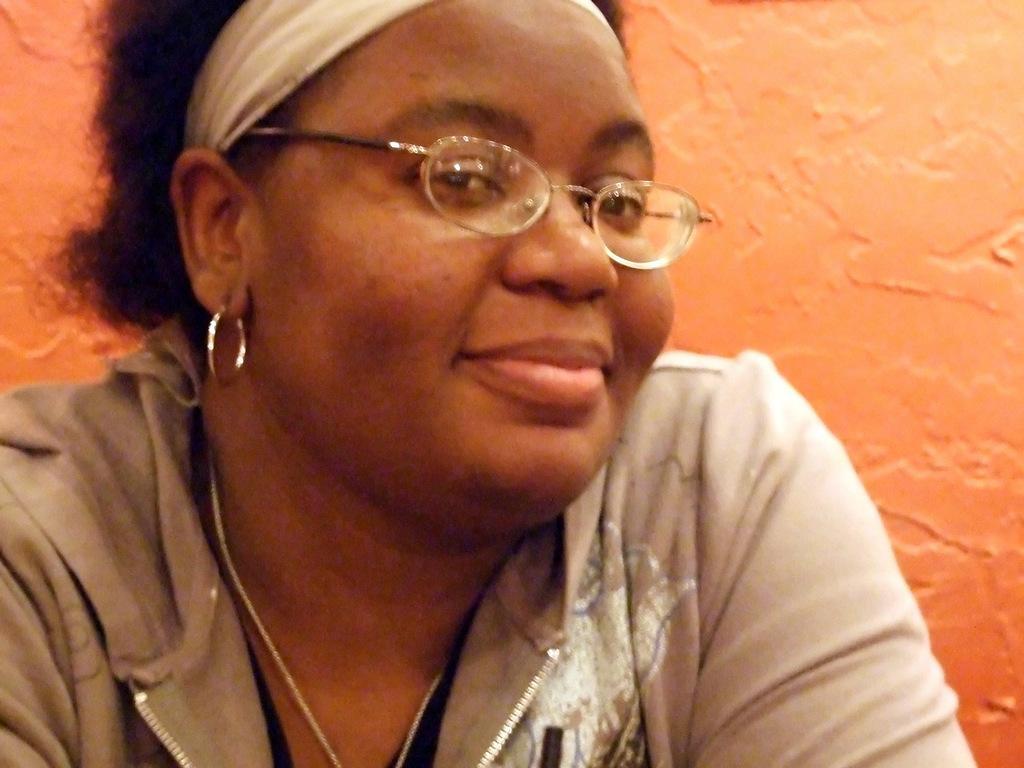Describe this image in one or two sentences. In this picture I can see a woman, she is smiling and also wearing the spectacles. 